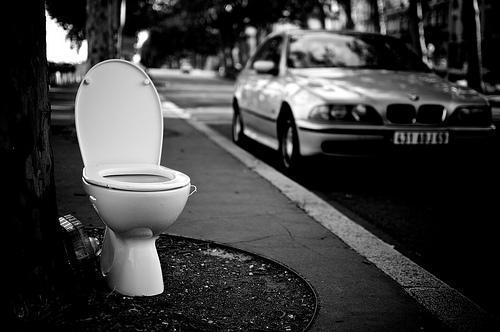How many cars are there?
Give a very brief answer. 1. 